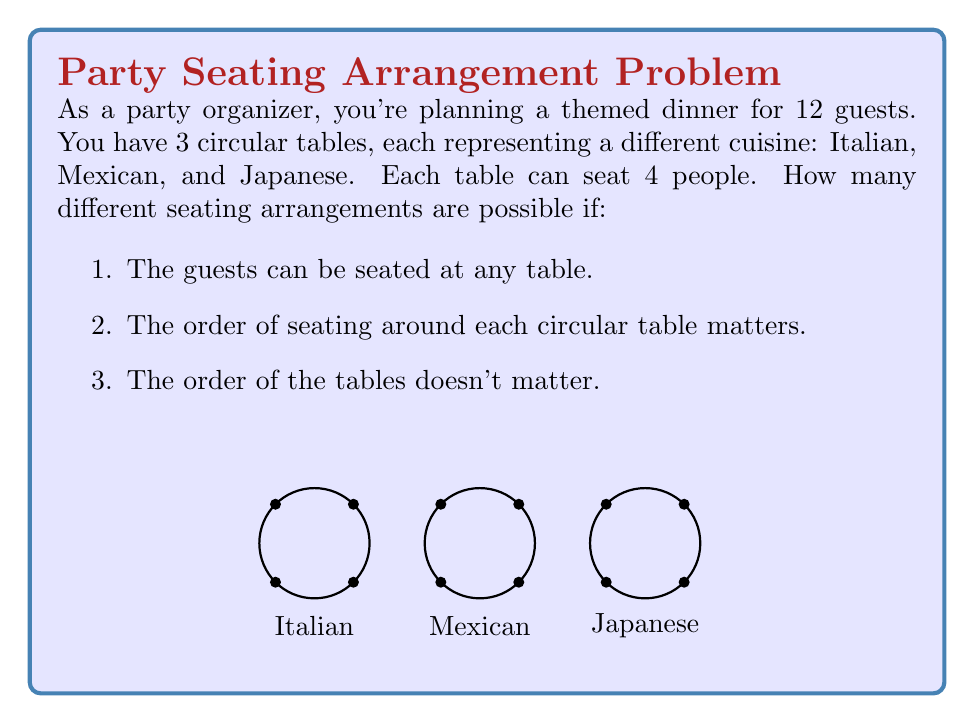Can you solve this math problem? Let's break this down step-by-step:

1) First, we need to choose which 4 guests will sit at each table. This is a partition of 12 people into 3 groups of 4. This can be calculated using the multinomial coefficient:

   $$\binom{12}{4,4,4} = \frac{12!}{4!4!4!}$$

2) For each of these partitions, we need to arrange the 4 people around each circular table. For a circular table with 4 seats, there are $(4-1)! = 3!$ distinct arrangements, as rotations are considered the same.

3) We need to do this for all 3 tables. So for each partition, we have $3! \times 3! \times 3!$ seating arrangements.

4) By the multiplication principle, the total number of arrangements is:

   $$\frac{12!}{4!4!4!} \times (3!)^3$$

5) Let's calculate this:
   
   $$\frac{12!}{4!4!4!} \times (3!)^3 = 34,650 \times 216 = 7,484,400$$

Therefore, there are 7,484,400 different possible seating arrangements.
Answer: 7,484,400 